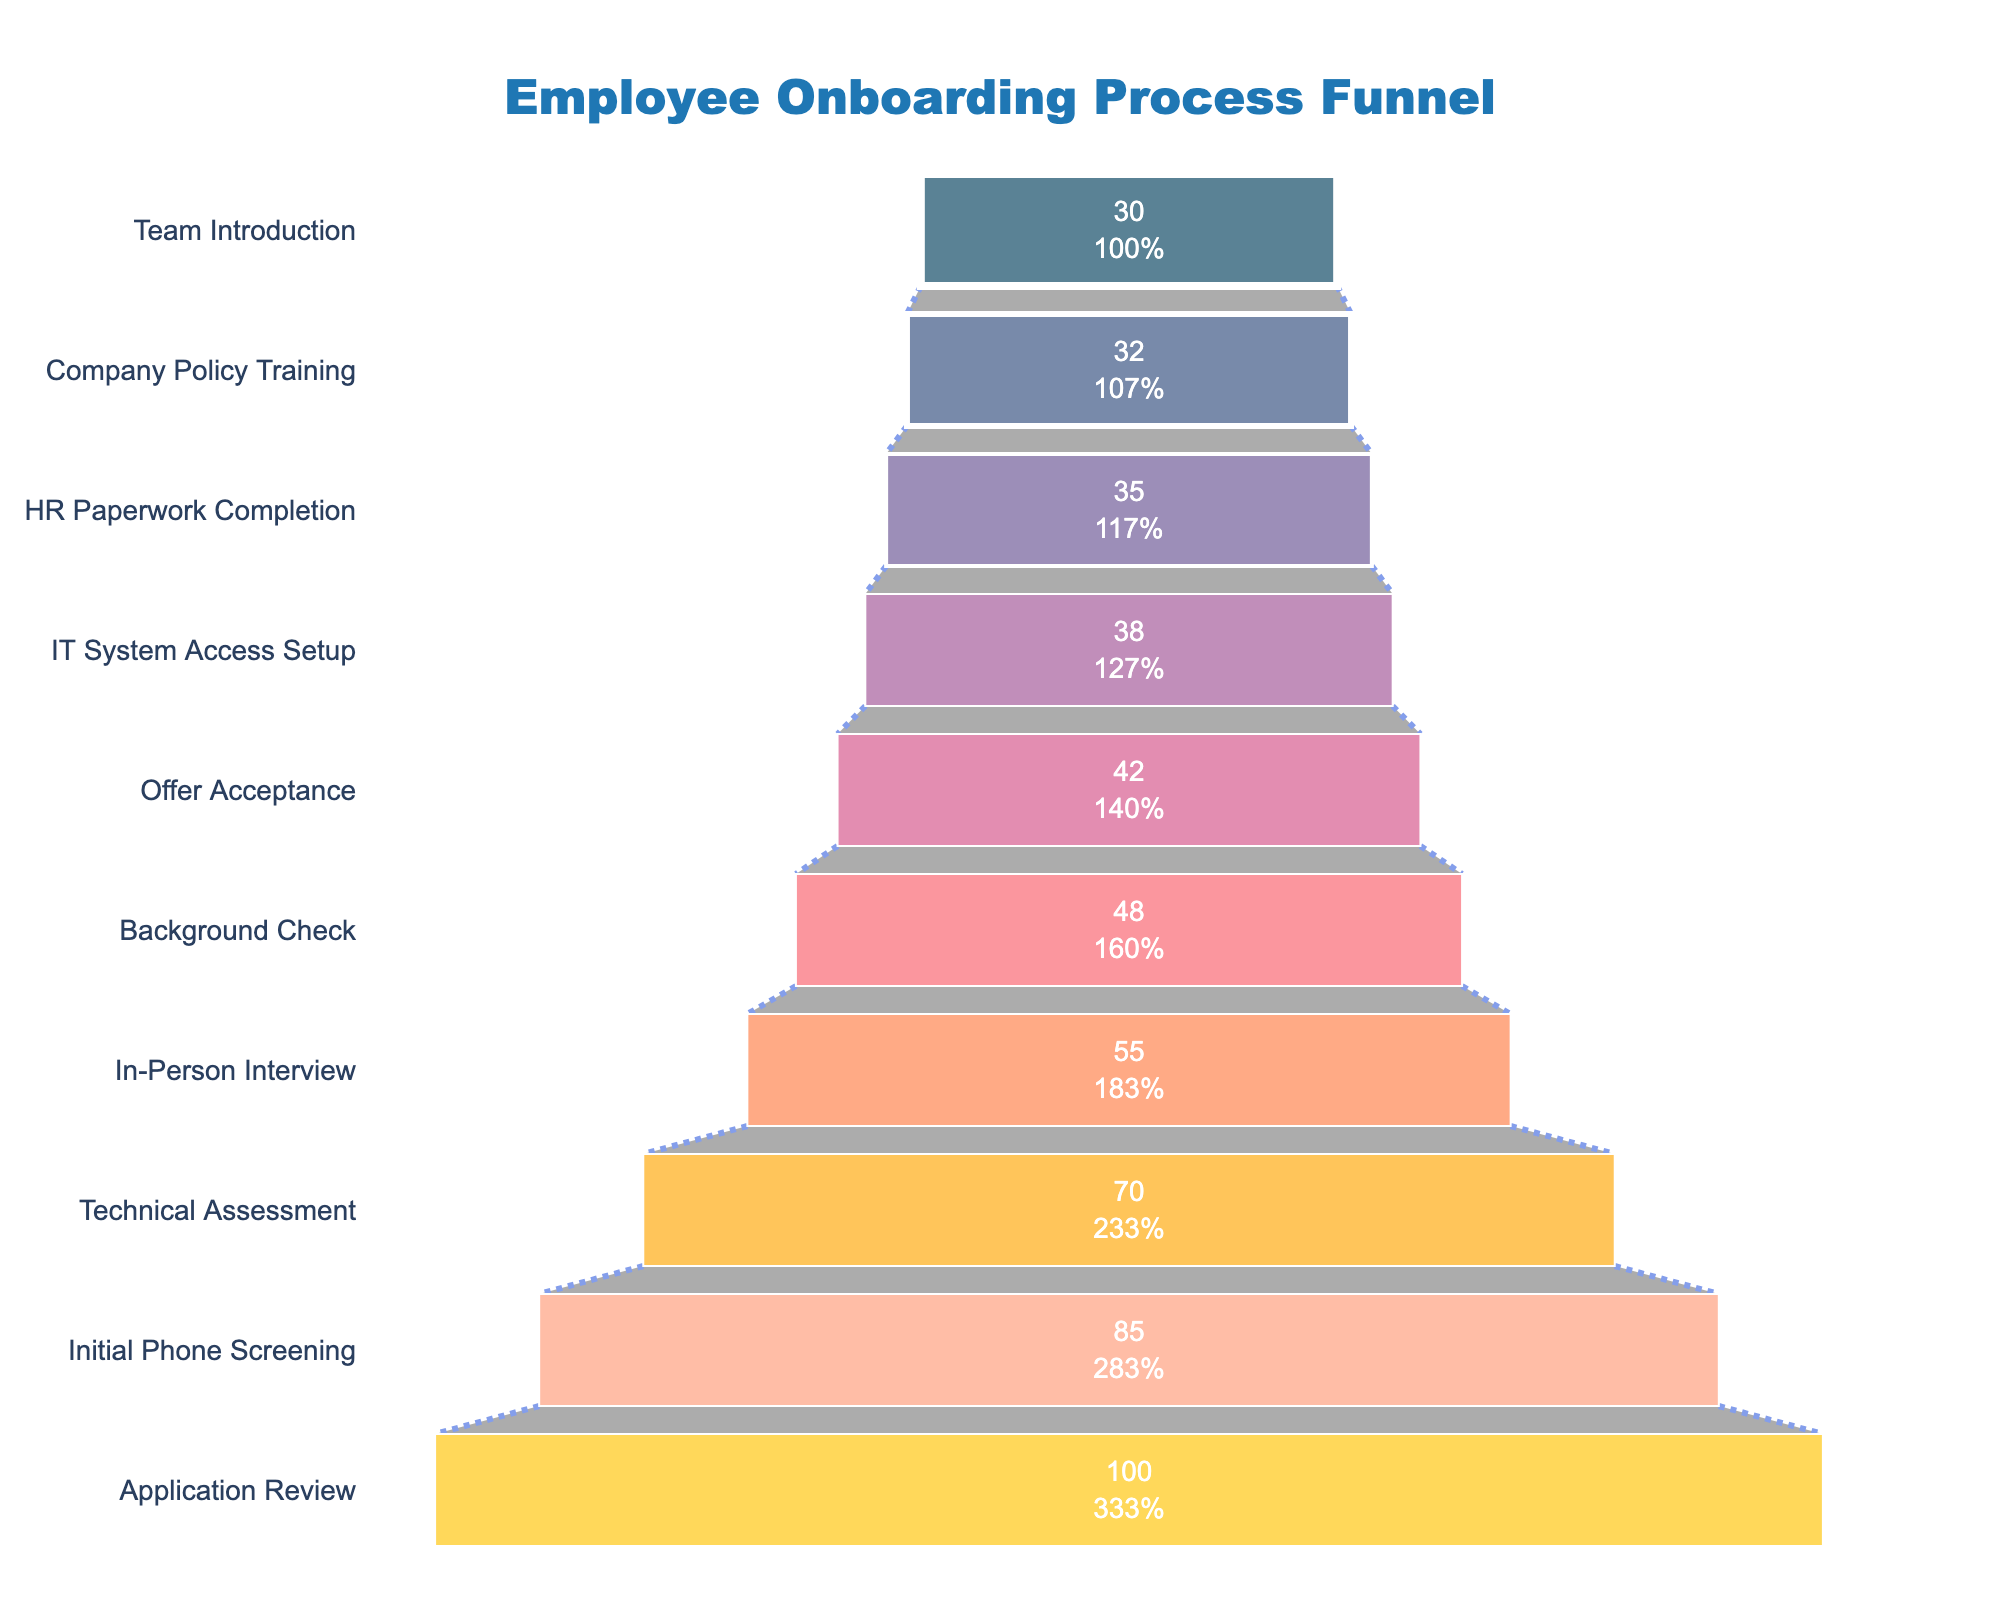what is the title of the funnel chart? The title of a chart is usually located at the top and summarizes the main idea of the figure. Here, it's located at the top-center of the chart and in a specific font.
Answer: Employee Onboarding Process Funnel Which stage has the highest completion rate? By observing the figure, we see the largest segment at the top, indicating the highest completion rate. This segment is for the "Application Review" stage.
Answer: Application Review How many stages are there in the onboarding process? To determine the number of stages, we count the individual segments or stages displayed in the funnel.
Answer: 10 What is the completion rate at the Technical Assessment stage? Locate the "Technical Assessment" stage along the y-axis and read the completion rate corresponding to it on the x-axis.
Answer: 70% Which stage has the lowest completion rate? The smallest segment at the bottom of the funnel represents the stage with the lowest completion rate. This stage is "Team Introduction".
Answer: Team Introduction What is the difference in completion rates between the Initial Phone Screening and Background Check stages? First, identify the completion rates for both stages: 85% for Initial Phone Screening and 48% for Background Check. Subtract the smaller completion rate from the larger one: 85% - 48% = 37%.
Answer: 37% What percentage of employees complete the Company Policy Training stage? Find the "Company Policy Training" stage on the y-axis and note the percentage completion rate shown on the x-axis.
Answer: 32% Which stage has a completion rate closest to 50%? Observe the funnel chart and identify the segment with a completion rate nearest 50%, which is the "In-Person Interview" stage at 55%.
Answer: In-Person Interview How does the completion rate change from the Offer Acceptance stage to the IT System Access Setup stage? Look at the completion rates for both stages: 42% for Offer Acceptance and 38% for IT System Access Setup. Subtract the latter from the former to find the difference: 42% - 38% = 4%.
Answer: Decreases by 4% What is the average completion rate from Technical Assessment to Team Introduction stages? First, identify the completion rates: Technical Assessment (70%), In-Person Interview (55%), Background Check (48%), Offer Acceptance (42%), IT System Access Setup (38%), HR Paperwork Completion (35%), Company Policy Training (32%), Team Introduction (30%). Sum these rates and divide by the number of stages: (70 + 55 + 48 + 42 + 38 + 35 + 32 + 30) / 8 = 43.75%.
Answer: 43.75% 